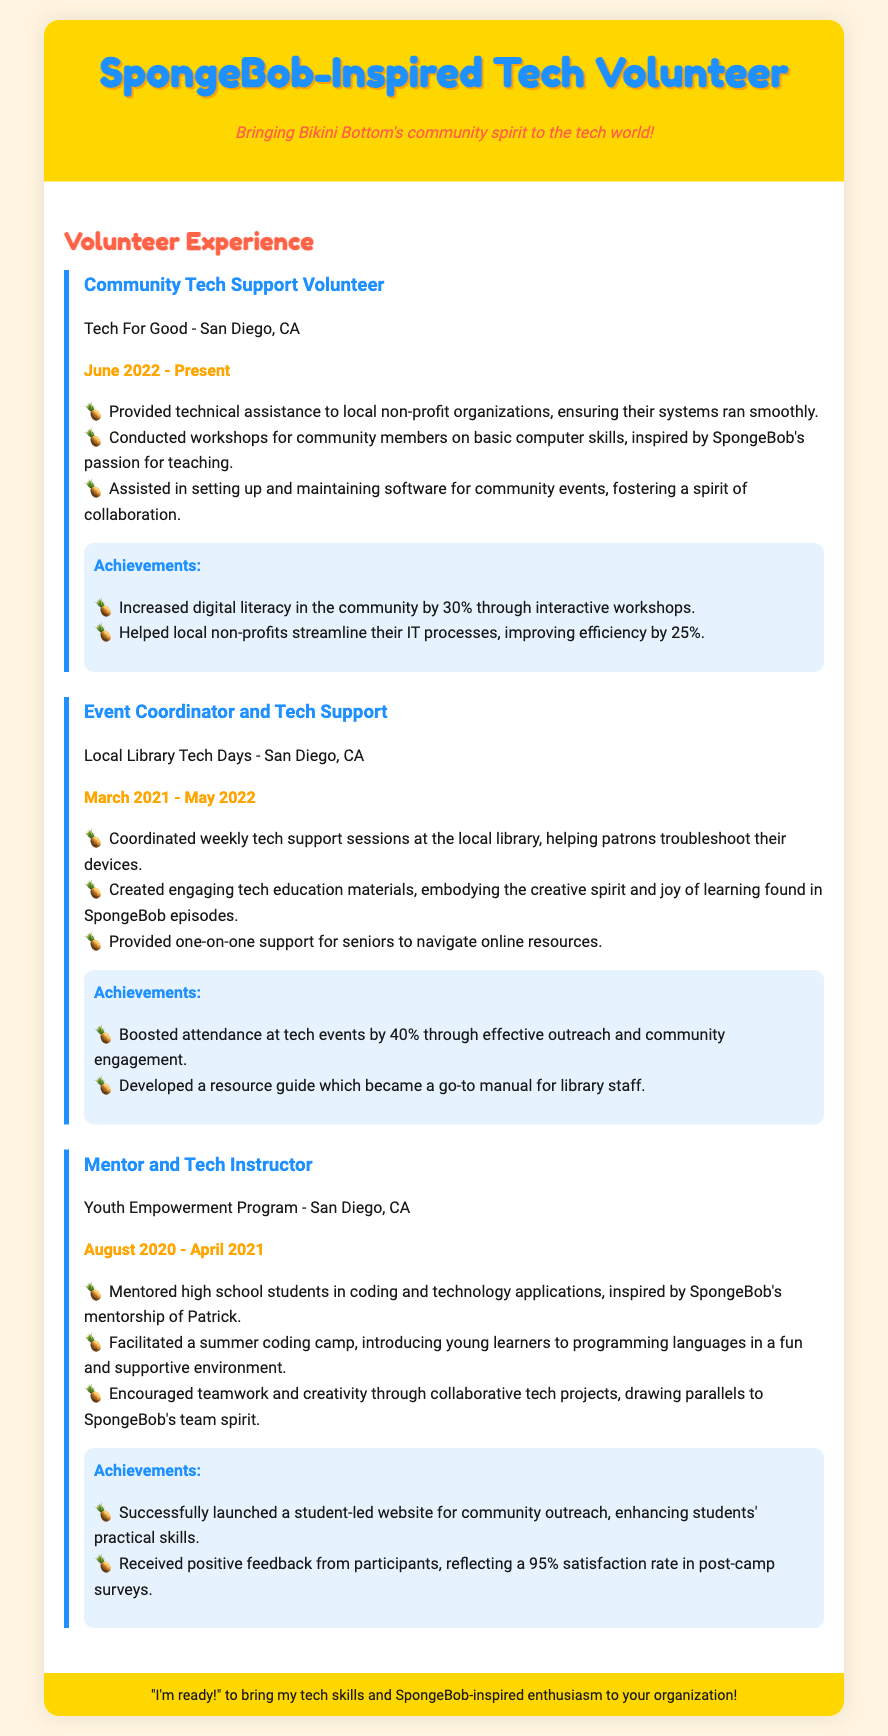What is the role of the first volunteer experience listed? The first volunteer experience listed is Community Tech Support Volunteer.
Answer: Community Tech Support Volunteer Which organization did the volunteer work with in 2022? The organization where the volunteer worked is Tech For Good.
Answer: Tech For Good How many years of experience does the resume cover in total? The resume covers experiences from March 2021 to Present, which is approximately 3 years.
Answer: 3 years What was the increase in digital literacy attributed to the Community Tech Support Volunteer? The increase in digital literacy in the community was 30%.
Answer: 30% What type of events did the Event Coordinator and Tech Support role focus on? The events focused on weekly tech support sessions at the local library.
Answer: Weekly tech support sessions How did the Mentor and Tech Instructor foster creativity in students? Creativity was fostered through collaborative tech projects.
Answer: Collaborative tech projects What feedback percentage did the Youth Empowerment Program receive? The program received a satisfaction rate of 95% in post-camp surveys.
Answer: 95% What color scheme is predominantly used in the resume? The predominant color scheme features yellow and blue shades.
Answer: Yellow and blue What did the Community Tech Support Volunteer assist with for community events? The volunteer assisted in setting up and maintaining software.
Answer: Setting up and maintaining software 